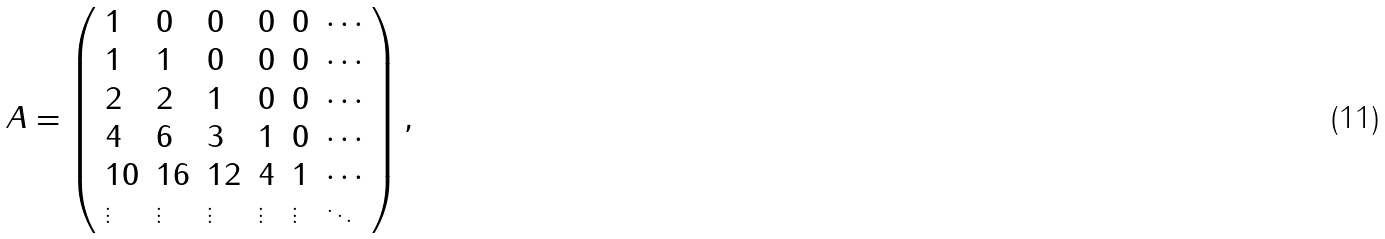<formula> <loc_0><loc_0><loc_500><loc_500>A = \left ( \begin{array} { l l l l l l } 1 & 0 & 0 & 0 & 0 & \cdots \\ 1 & 1 & 0 & 0 & 0 & \cdots \\ 2 & 2 & 1 & 0 & 0 & \cdots \\ 4 & 6 & 3 & 1 & 0 & \cdots \\ 1 0 & 1 6 & 1 2 & 4 & 1 & \cdots \\ \vdots & \vdots & \vdots & \vdots & \vdots & \ddots \end{array} \right ) ,</formula> 